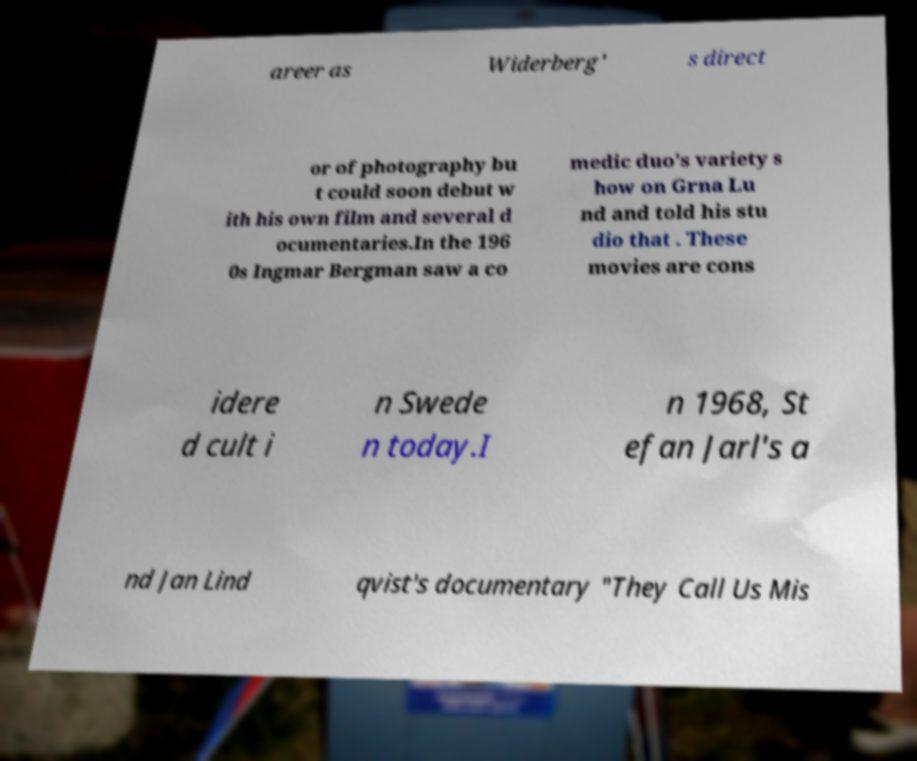Please identify and transcribe the text found in this image. areer as Widerberg' s direct or of photography bu t could soon debut w ith his own film and several d ocumentaries.In the 196 0s Ingmar Bergman saw a co medic duo's variety s how on Grna Lu nd and told his stu dio that . These movies are cons idere d cult i n Swede n today.I n 1968, St efan Jarl's a nd Jan Lind qvist's documentary "They Call Us Mis 